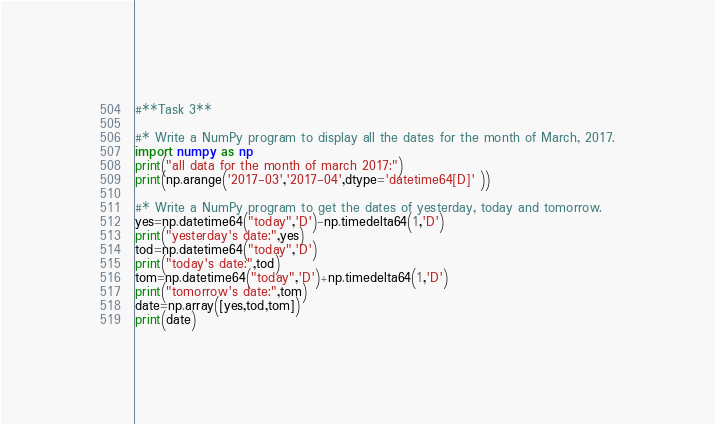<code> <loc_0><loc_0><loc_500><loc_500><_Python_>#**Task 3**

#* Write a NumPy program to display all the dates for the month of March, 2017.
import numpy as np
print("all data for the month of march 2017:")
print(np.arange('2017-03','2017-04',dtype='datetime64[D]' ))

#* Write a NumPy program to get the dates of yesterday, today and tomorrow.
yes=np.datetime64("today",'D')-np.timedelta64(1,'D')
print("yesterday's date:",yes)
tod=np.datetime64("today",'D')
print("today's date:",tod)
tom=np.datetime64("today",'D')+np.timedelta64(1,'D')
print("tomorrow's date:",tom)
date=np.array([yes,tod,tom])
print(date)
</code> 